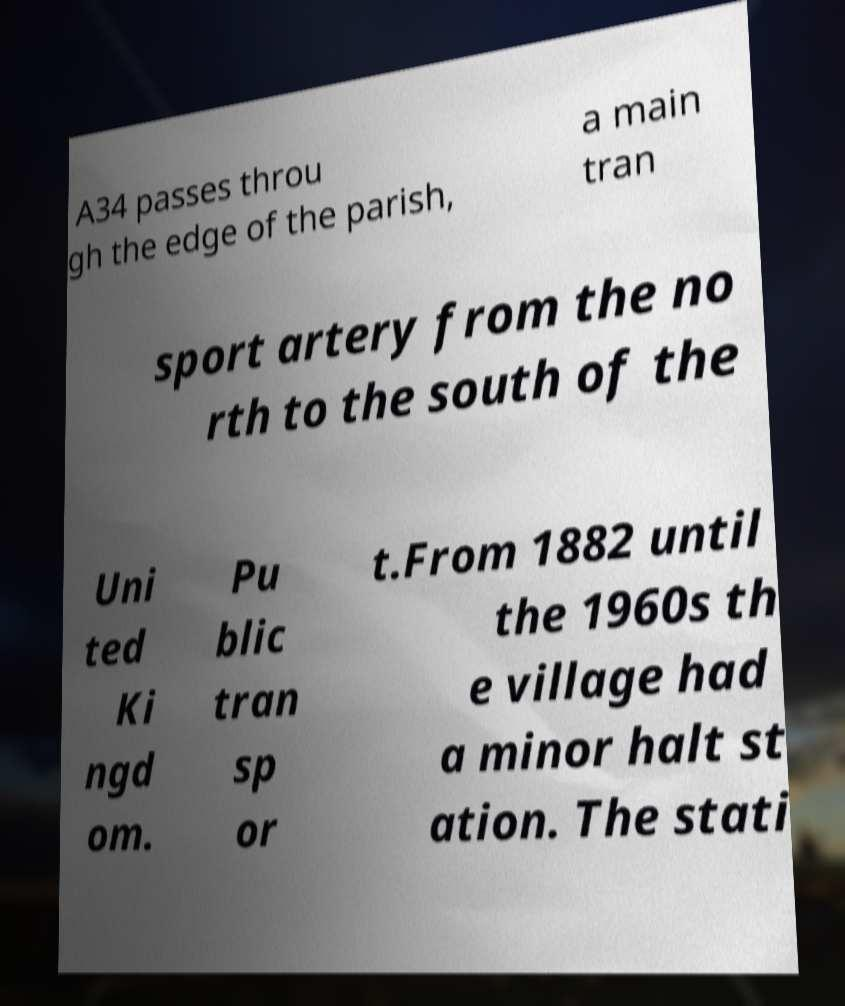Could you extract and type out the text from this image? A34 passes throu gh the edge of the parish, a main tran sport artery from the no rth to the south of the Uni ted Ki ngd om. Pu blic tran sp or t.From 1882 until the 1960s th e village had a minor halt st ation. The stati 